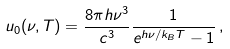<formula> <loc_0><loc_0><loc_500><loc_500>u _ { 0 } ( \nu , T ) = \frac { 8 \pi h \nu ^ { 3 } } { c ^ { 3 } } \frac { 1 } { e ^ { h \nu / k _ { B } T } - 1 } \, ,</formula> 